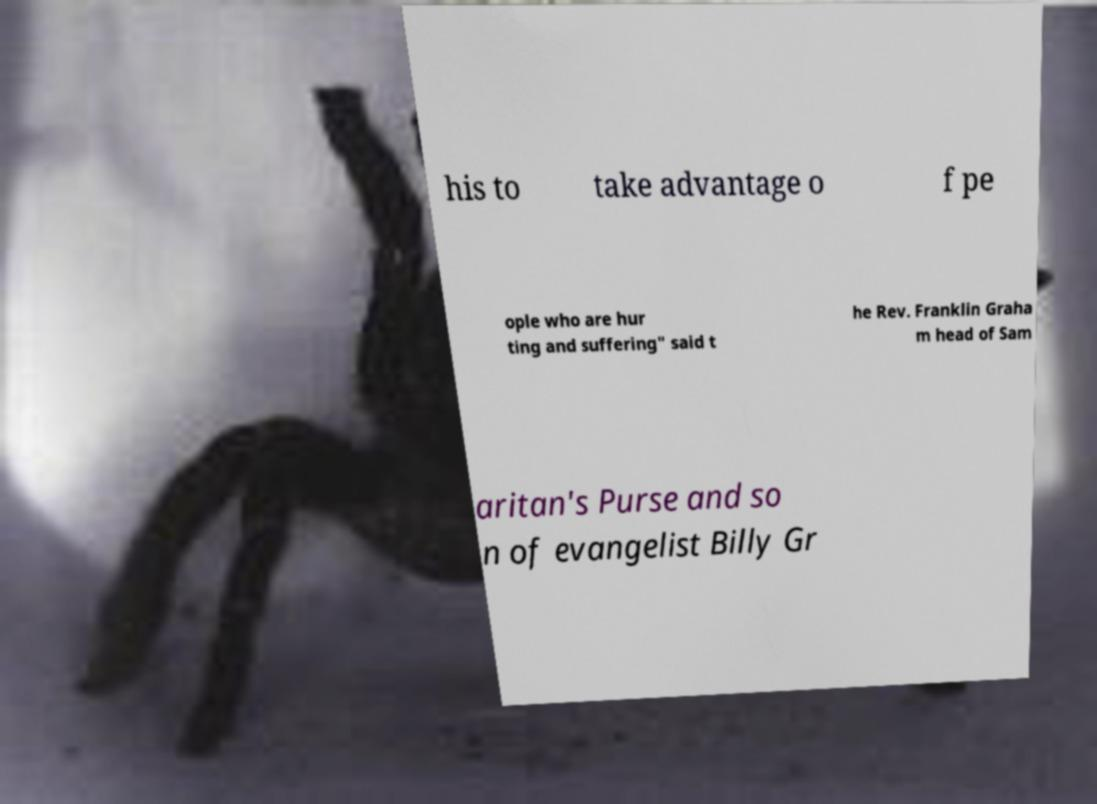I need the written content from this picture converted into text. Can you do that? his to take advantage o f pe ople who are hur ting and suffering" said t he Rev. Franklin Graha m head of Sam aritan's Purse and so n of evangelist Billy Gr 